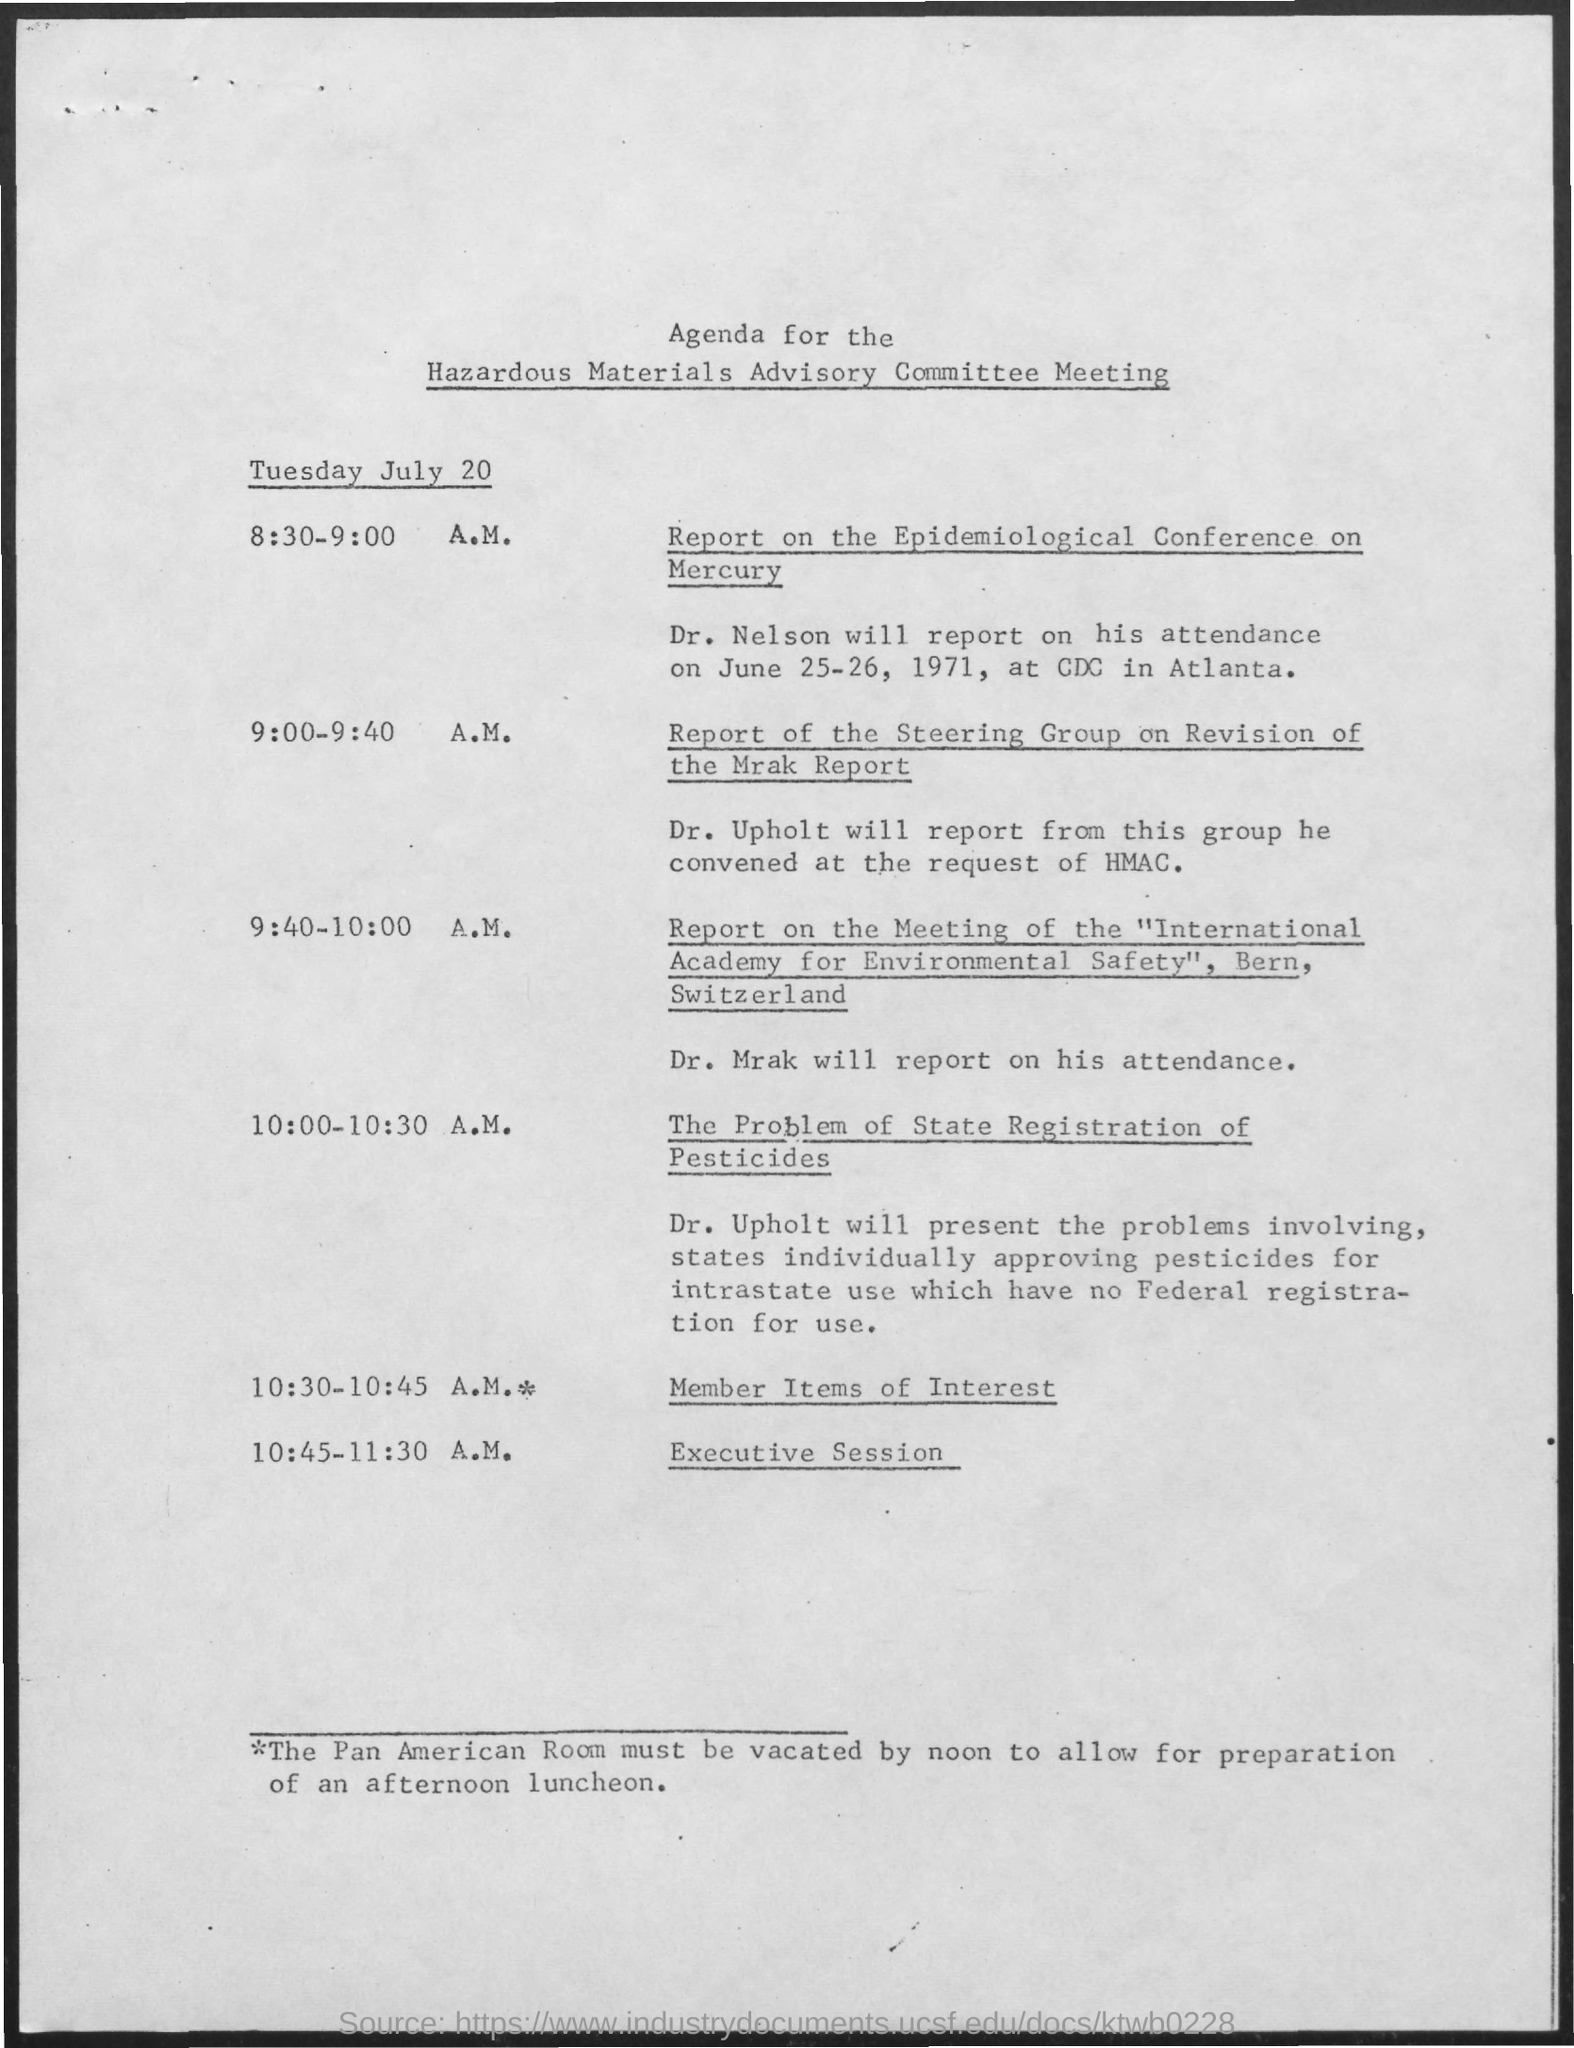Indicate a few pertinent items in this graphic. The Hazardous Materials Advisory Committee Meeting is the name of the meeting. 